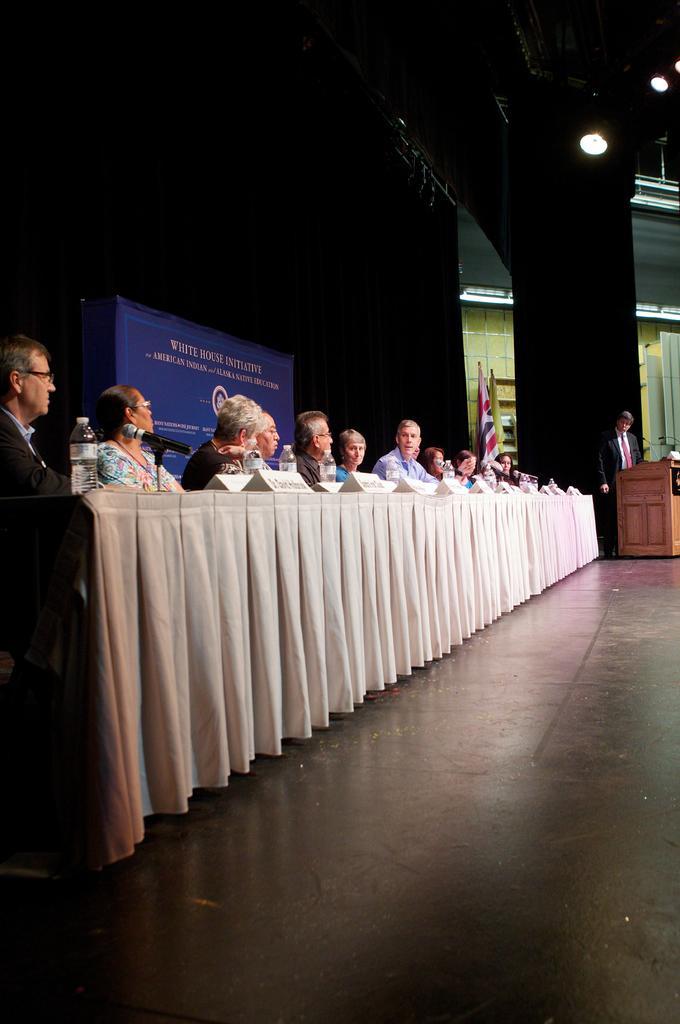In one or two sentences, can you explain what this image depicts? In this picture we can see a group of people sitting and in front of the people there is a table, which is covered by a cloth. On the table there are name plates, bottles and a microphone. On the right side of the people there are flags and a person is standing behind the podium. Behind the people there is a board and at the top there are lights. 